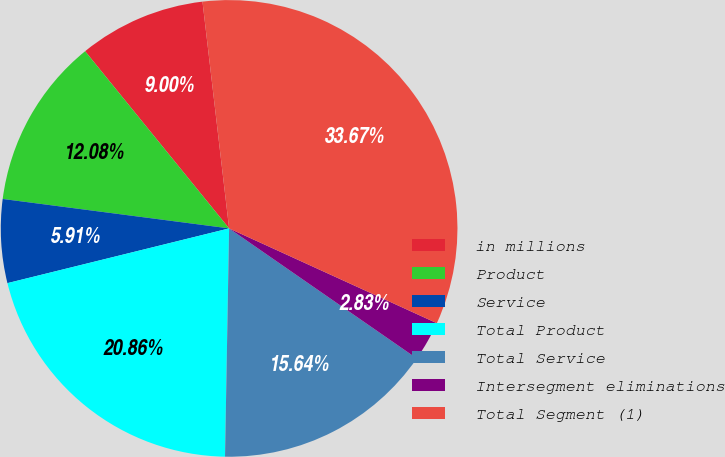<chart> <loc_0><loc_0><loc_500><loc_500><pie_chart><fcel>in millions<fcel>Product<fcel>Service<fcel>Total Product<fcel>Total Service<fcel>Intersegment eliminations<fcel>Total Segment (1)<nl><fcel>9.0%<fcel>12.08%<fcel>5.91%<fcel>20.86%<fcel>15.64%<fcel>2.83%<fcel>33.67%<nl></chart> 